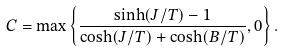<formula> <loc_0><loc_0><loc_500><loc_500>C = \max \left \{ \frac { \sinh ( J / T ) - 1 } { \cosh ( J / T ) + \cosh ( B / T ) } , 0 \right \} .</formula> 